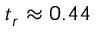Convert formula to latex. <formula><loc_0><loc_0><loc_500><loc_500>t _ { r } \approx 0 . 4 4</formula> 